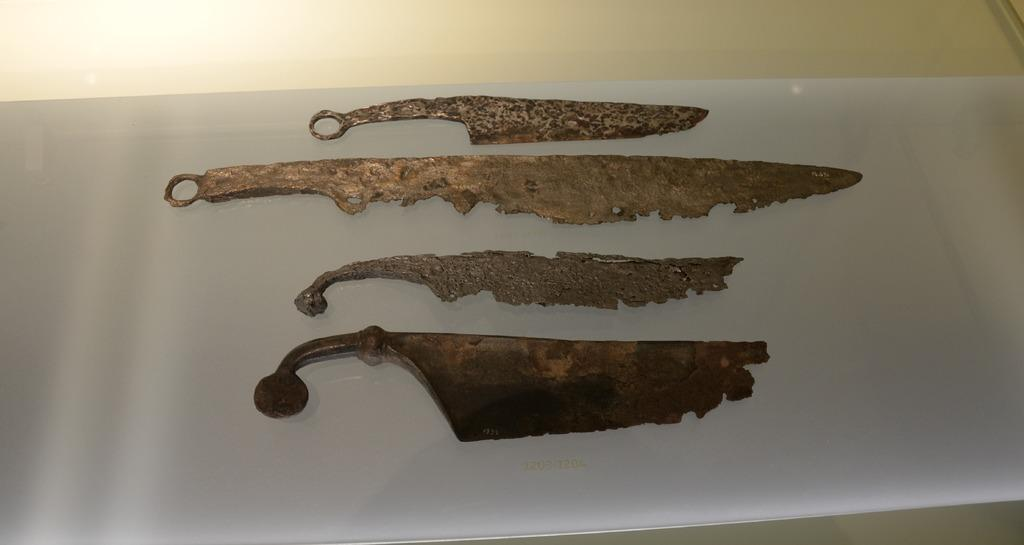What type of objects are on the table in the image? There are metal objects on a table in the image. What can be seen in the background of the image? There is a floor visible in the background of the image. What type of marble is being used by the laborer in the image? There is no marble or laborer present in the image; it only features metal objects on a table and a visible floor in the background. 